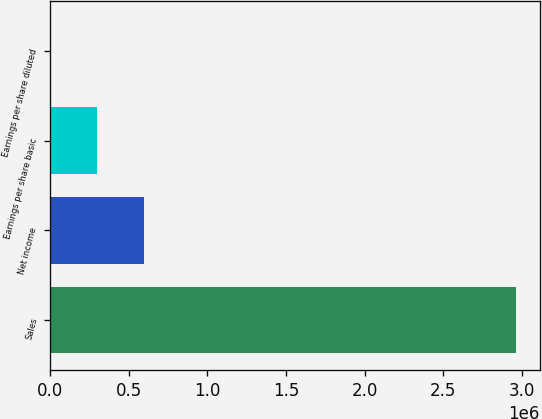Convert chart to OTSL. <chart><loc_0><loc_0><loc_500><loc_500><bar_chart><fcel>Sales<fcel>Net income<fcel>Earnings per share basic<fcel>Earnings per share diluted<nl><fcel>2.96742e+06<fcel>593487<fcel>296746<fcel>4.62<nl></chart> 